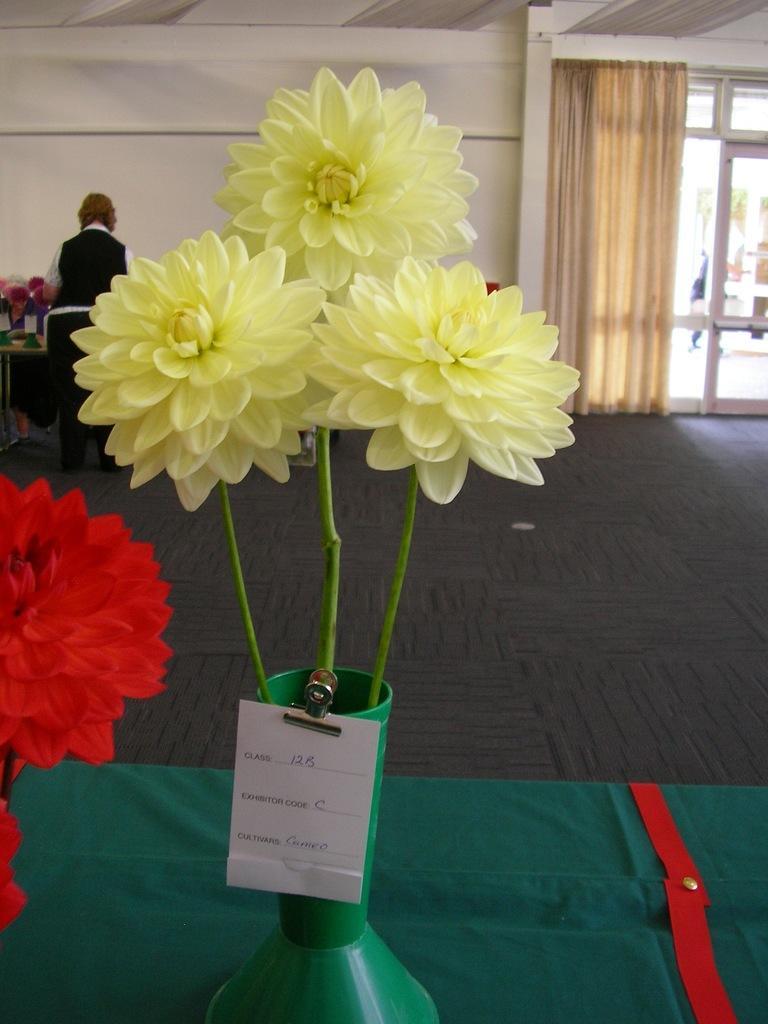Could you give a brief overview of what you see in this image? In this image we can see flower vases with name boards placed on the table. In the background there is a person standing on the floor, curtains to the window and wall. 